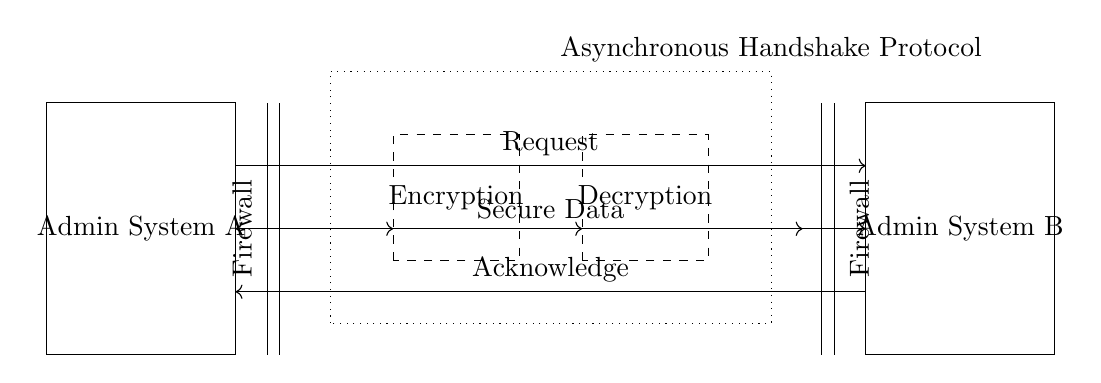What is the primary function of the Encryption block? The Encryption block is responsible for securing the data before transmission. This is indicated by its label and position in the circuit.
Answer: Secure data What type of protocol is indicated in the circuit? The protocol indicated is an Asynchronous Handshake Protocol, as stated in the dotted box encompassing the main components.
Answer: Asynchronous Handshake Protocol What do the arrows between the request line and acknowledge line represent? The arrows show the direction of communication between the two administrative systems—where one sends a request and the other acknowledges it. This denotes a two-way communication process essential for handshaking.
Answer: Request and Acknowledge How many firewalls are present in the circuit? There are two firewall symbols depicted, one on each side of the administrative systems, providing a secure channel for data transfer.
Answer: Two What is the role of the Decryption block in this circuit? The Decryption block functions to decode the secure data received from Admin System A, allowing Admin System B to access the original data after it has been encrypted.
Answer: Decode secure data What type of systems are represented in the circuit diagram? The circuit diagram represents administrative systems, specifically labeled as Admin System A and Admin System B, which are involved in the secure data transfer process.
Answer: Administrative systems What does the dashed shape around the Encryption and Decryption blocks indicate? The dashed shape indicates that these blocks are functional units within the overall system, designating encryption and decryption tasks as integral parts of the secure communications process.
Answer: Functional units 